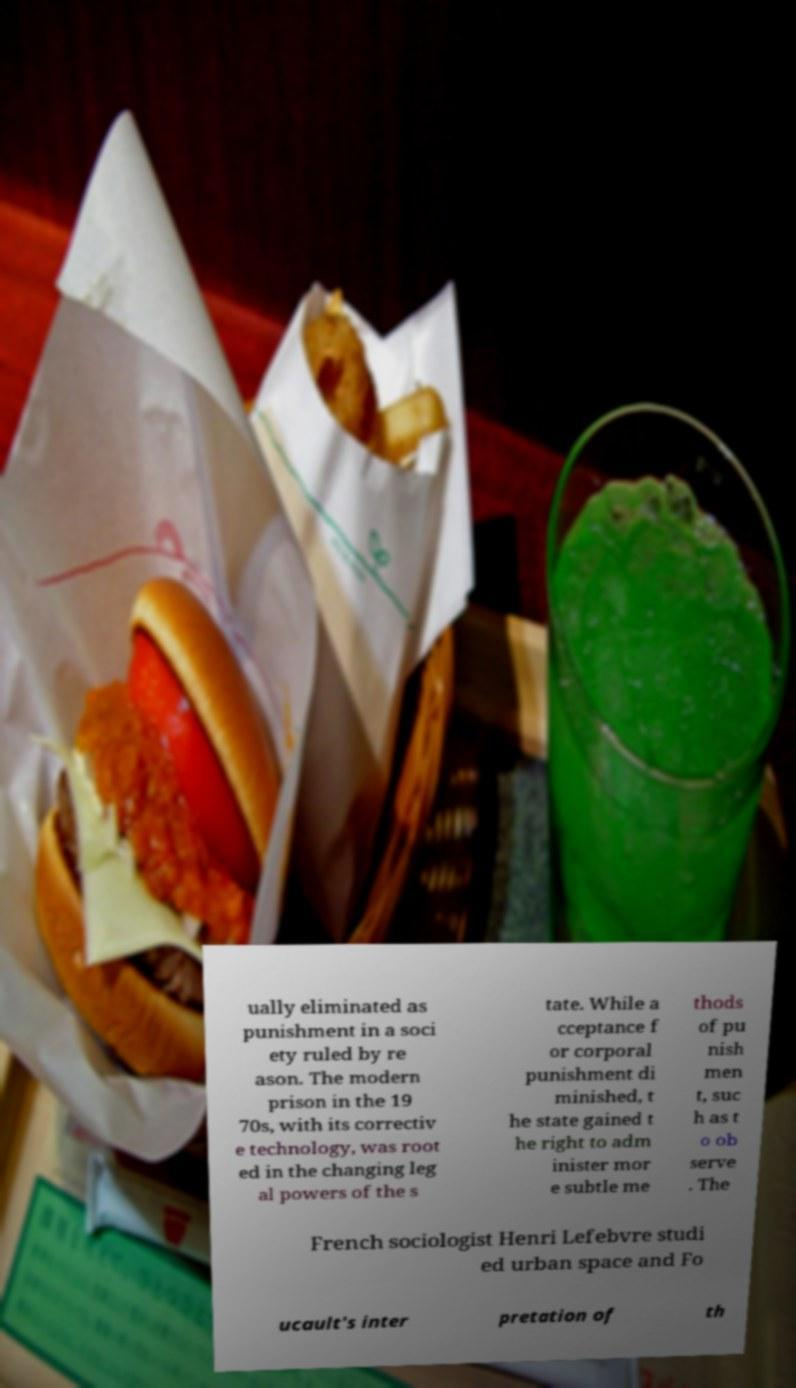Please identify and transcribe the text found in this image. ually eliminated as punishment in a soci ety ruled by re ason. The modern prison in the 19 70s, with its correctiv e technology, was root ed in the changing leg al powers of the s tate. While a cceptance f or corporal punishment di minished, t he state gained t he right to adm inister mor e subtle me thods of pu nish men t, suc h as t o ob serve . The French sociologist Henri Lefebvre studi ed urban space and Fo ucault's inter pretation of th 